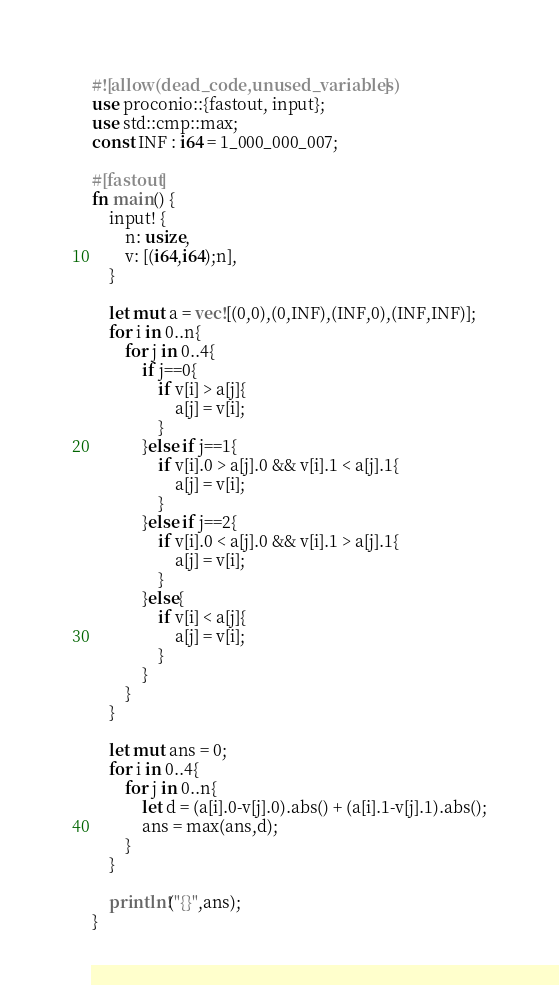<code> <loc_0><loc_0><loc_500><loc_500><_Rust_>#![allow(dead_code,unused_variables)]
use proconio::{fastout, input};
use std::cmp::max;
const INF : i64 = 1_000_000_007;

#[fastout]
fn main() {
    input! {
        n: usize,
        v: [(i64,i64);n],
    }

    let mut a = vec![(0,0),(0,INF),(INF,0),(INF,INF)];
    for i in 0..n{
        for j in 0..4{
            if j==0{
                if v[i] > a[j]{
                    a[j] = v[i];
                }
            }else if j==1{
                if v[i].0 > a[j].0 && v[i].1 < a[j].1{
                    a[j] = v[i];
                }
            }else if j==2{
                if v[i].0 < a[j].0 && v[i].1 > a[j].1{
                    a[j] = v[i];
                }
            }else{
                if v[i] < a[j]{
                    a[j] = v[i];
                }
            }
        }
    }

    let mut ans = 0;
    for i in 0..4{
        for j in 0..n{
            let d = (a[i].0-v[j].0).abs() + (a[i].1-v[j].1).abs();
            ans = max(ans,d);
        }
    }
    
    println!("{}",ans);
}
</code> 